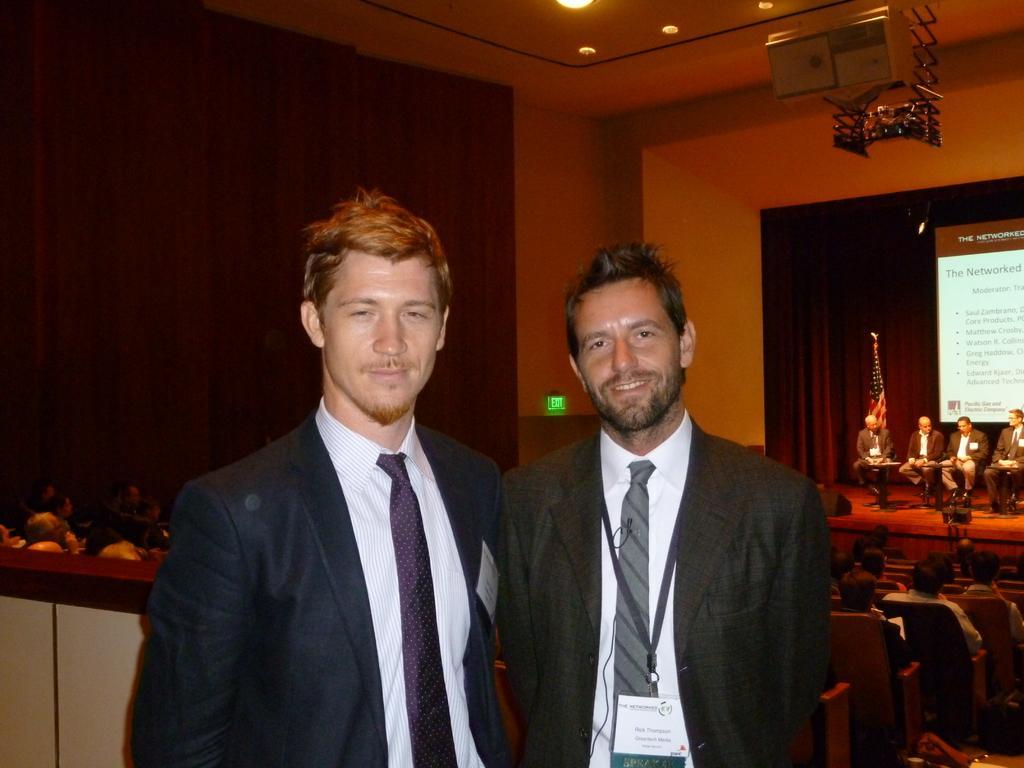In one or two sentences, can you explain what this image depicts? This picture might be taken inside a conference hall. In this image, in the middle, we can see two men are standing. On the right side corner, we can see a group of people are sitting on the chairs. On the right side, we can see a group of people sitting on the chairs and a screen. On the left side, we can also see group of people sitting on the chair. In the background, we can see a curtain. On the top, we can see a projector and a roof with few lights. 